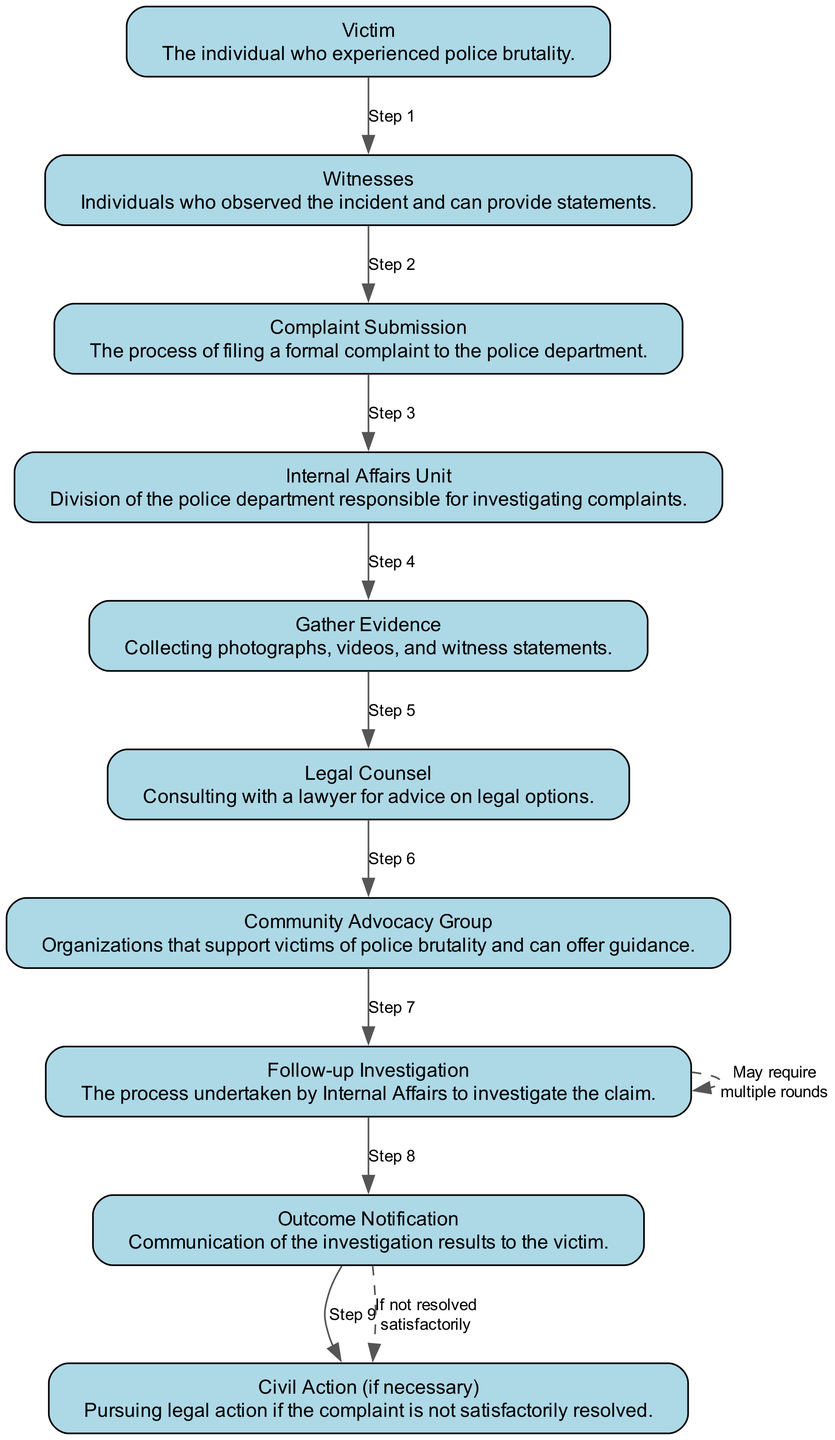What is the first step in the complaint process? The first step is represented by the "Victim," who is the individual who experienced police brutality. This node starts the flow of the process.
Answer: Victim How many total nodes are in the diagram? The diagram consists of ten nodes, each representing a unique step or element involved in the complaint process.
Answer: 10 What follows the "Gather Evidence" step? After "Gather Evidence," the next step in the process is to consult with "Legal Counsel" for legal advice regarding the incident.
Answer: Legal Counsel What process does the "Internal Affairs Unit" undertake? The "Internal Affairs Unit" is responsible for conducting the "Follow-up Investigation" to look into the complaint made by the victim.
Answer: Follow-up Investigation What is the outcome of the "Follow-up Investigation"? The outcome of the investigation is communicated to the victim through "Outcome Notification," which details the results of the internal investigation.
Answer: Outcome Notification What happens if the complaint is not resolved satisfactorily? If the complaint is not resolved satisfactorily, the next step involves pursuing "Civil Action," which provides the victim with further legal options to take against the police department.
Answer: Civil Action How many steps are indicated after the "Community Advocacy Group"? There are three steps indicated after "Community Advocacy Group": "Follow-up Investigation," "Outcome Notification," and "Civil Action (if necessary)."
Answer: 3 What representation does the dashed line between "Follow-up Investigation" and "Civil Action" indicate? The dashed line signifies a condition where pursuing "Civil Action" occurs only if the complaint is not resolved satisfactorily through the internal investigation process.
Answer: Condition Which role is responsible for collecting evidence? The role responsible for gathering evidence is the "Gather Evidence," which involves collecting photographs, videos, and witness statements relevant to the police brutality incident.
Answer: Gather Evidence 